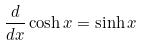Convert formula to latex. <formula><loc_0><loc_0><loc_500><loc_500>\frac { d } { d x } \cosh x = \sinh x</formula> 